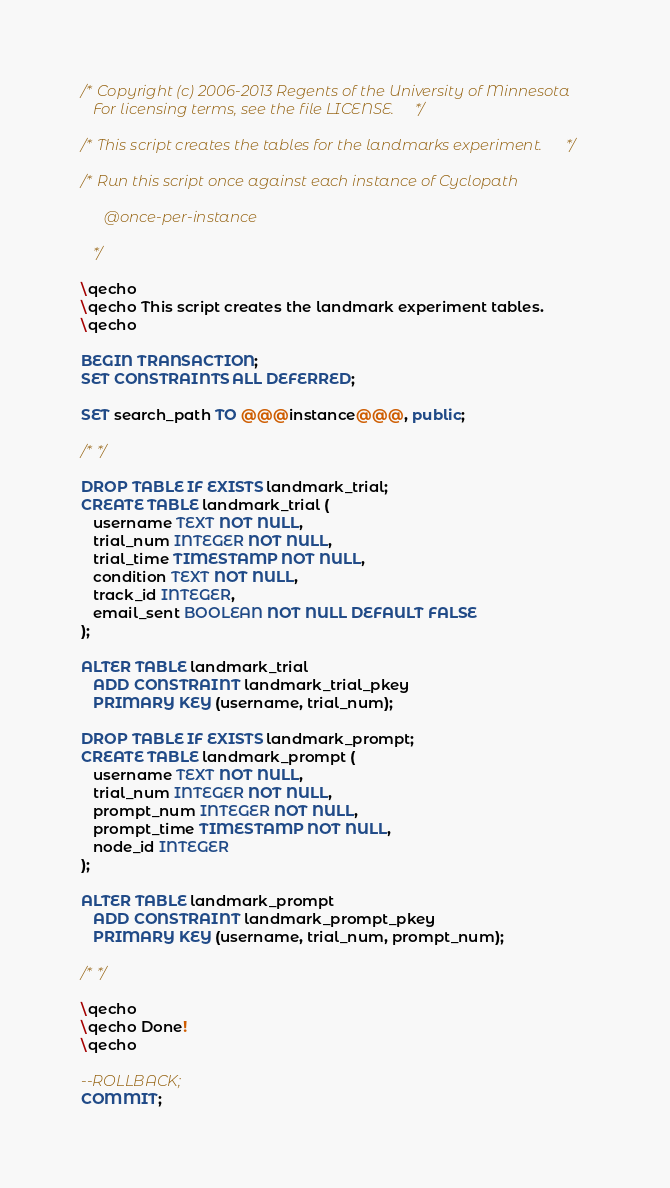<code> <loc_0><loc_0><loc_500><loc_500><_SQL_>/* Copyright (c) 2006-2013 Regents of the University of Minnesota
   For licensing terms, see the file LICENSE. */

/* This script creates the tables for the landmarks experiment. */

/* Run this script once against each instance of Cyclopath

      @once-per-instance

   */

\qecho
\qecho This script creates the landmark experiment tables.
\qecho

BEGIN TRANSACTION;
SET CONSTRAINTS ALL DEFERRED;

SET search_path TO @@@instance@@@, public;

/* */

DROP TABLE IF EXISTS landmark_trial;
CREATE TABLE landmark_trial (
   username TEXT NOT NULL,
   trial_num INTEGER NOT NULL,
   trial_time TIMESTAMP NOT NULL,
   condition TEXT NOT NULL,
   track_id INTEGER,
   email_sent BOOLEAN NOT NULL DEFAULT FALSE
);

ALTER TABLE landmark_trial 
   ADD CONSTRAINT landmark_trial_pkey 
   PRIMARY KEY (username, trial_num);

DROP TABLE IF EXISTS landmark_prompt;
CREATE TABLE landmark_prompt (
   username TEXT NOT NULL,
   trial_num INTEGER NOT NULL,
   prompt_num INTEGER NOT NULL,
   prompt_time TIMESTAMP NOT NULL,
   node_id INTEGER
);

ALTER TABLE landmark_prompt 
   ADD CONSTRAINT landmark_prompt_pkey 
   PRIMARY KEY (username, trial_num, prompt_num);

/* */

\qecho
\qecho Done!
\qecho

--ROLLBACK;
COMMIT;

</code> 